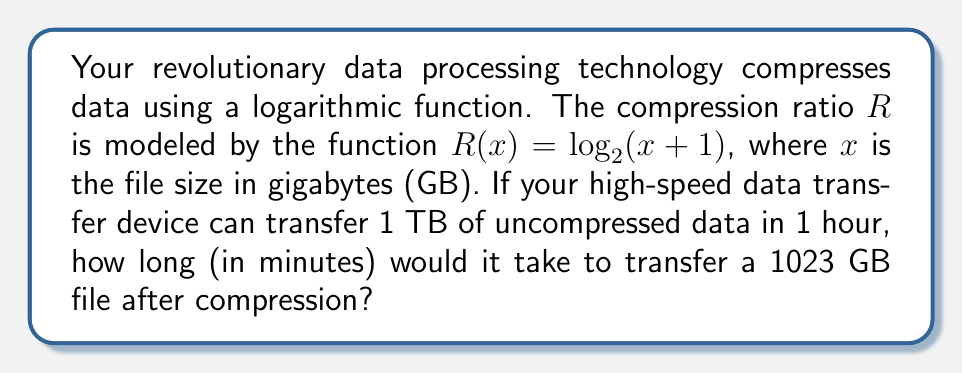Show me your answer to this math problem. 1) First, calculate the compression ratio for a 1023 GB file:
   $R(1023) = \log_2(1023 + 1) = \log_2(1024) = 10$

2) This means the file will be compressed to $\frac{1}{10}$ of its original size:
   $1023 \div 10 = 102.3$ GB

3) Convert the transfer rate to GB per hour:
   1 TB = 1024 GB, so the transfer rate is 1024 GB/hour

4) Set up the proportion to find the time (in hours) to transfer 102.3 GB:
   $$\frac{1024 \text{ GB}}{1 \text{ hour}} = \frac{102.3 \text{ GB}}{x \text{ hours}}$$

5) Solve for $x$:
   $$x = \frac{102.3}{1024} = 0.09990234375 \text{ hours}$$

6) Convert hours to minutes:
   $0.09990234375 \times 60 = 5.994140625$ minutes

7) Round to the nearest second:
   5.99 minutes or approximately 6 minutes
Answer: 5.99 minutes 